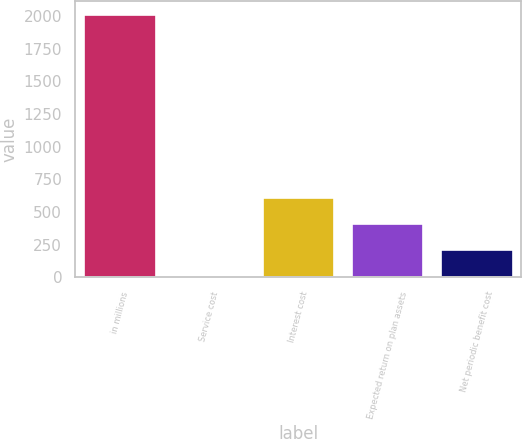Convert chart. <chart><loc_0><loc_0><loc_500><loc_500><bar_chart><fcel>in millions<fcel>Service cost<fcel>Interest cost<fcel>Expected return on plan assets<fcel>Net periodic benefit cost<nl><fcel>2011<fcel>4.4<fcel>606.38<fcel>405.72<fcel>205.06<nl></chart> 